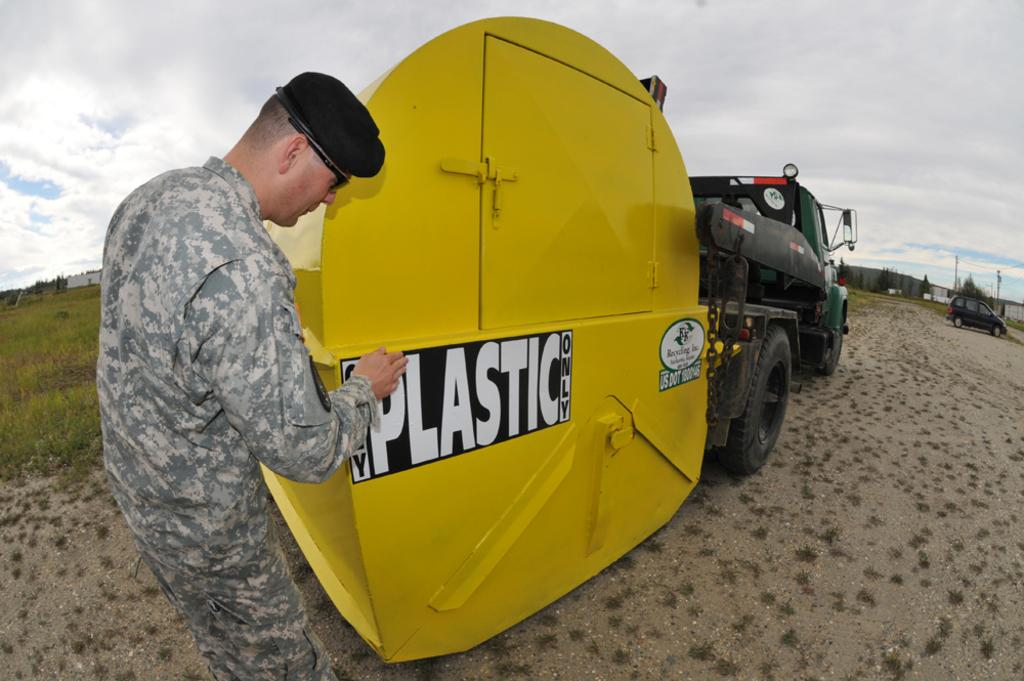What is the main subject of the image? The main subject of the image is a truck. Are there any people in the image? Yes, there is a soldier standing in the image. What type of terrain is depicted in the image? There is sand on the ground in the image. What is visible at the top of the image? The sky is visible at the top of the image. What type of haircut does the government have in the image? There is no reference to a government or a haircut in the image. 